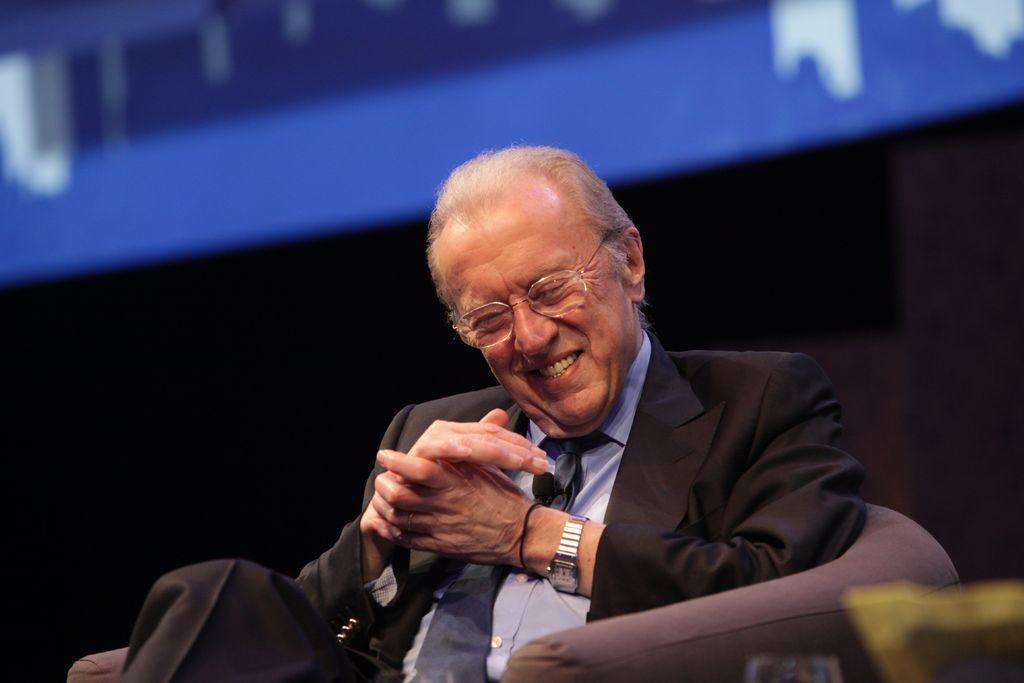Please provide a concise description of this image. In this image there is one person sitting on chair and he is laughing, and there is a blurry background. 